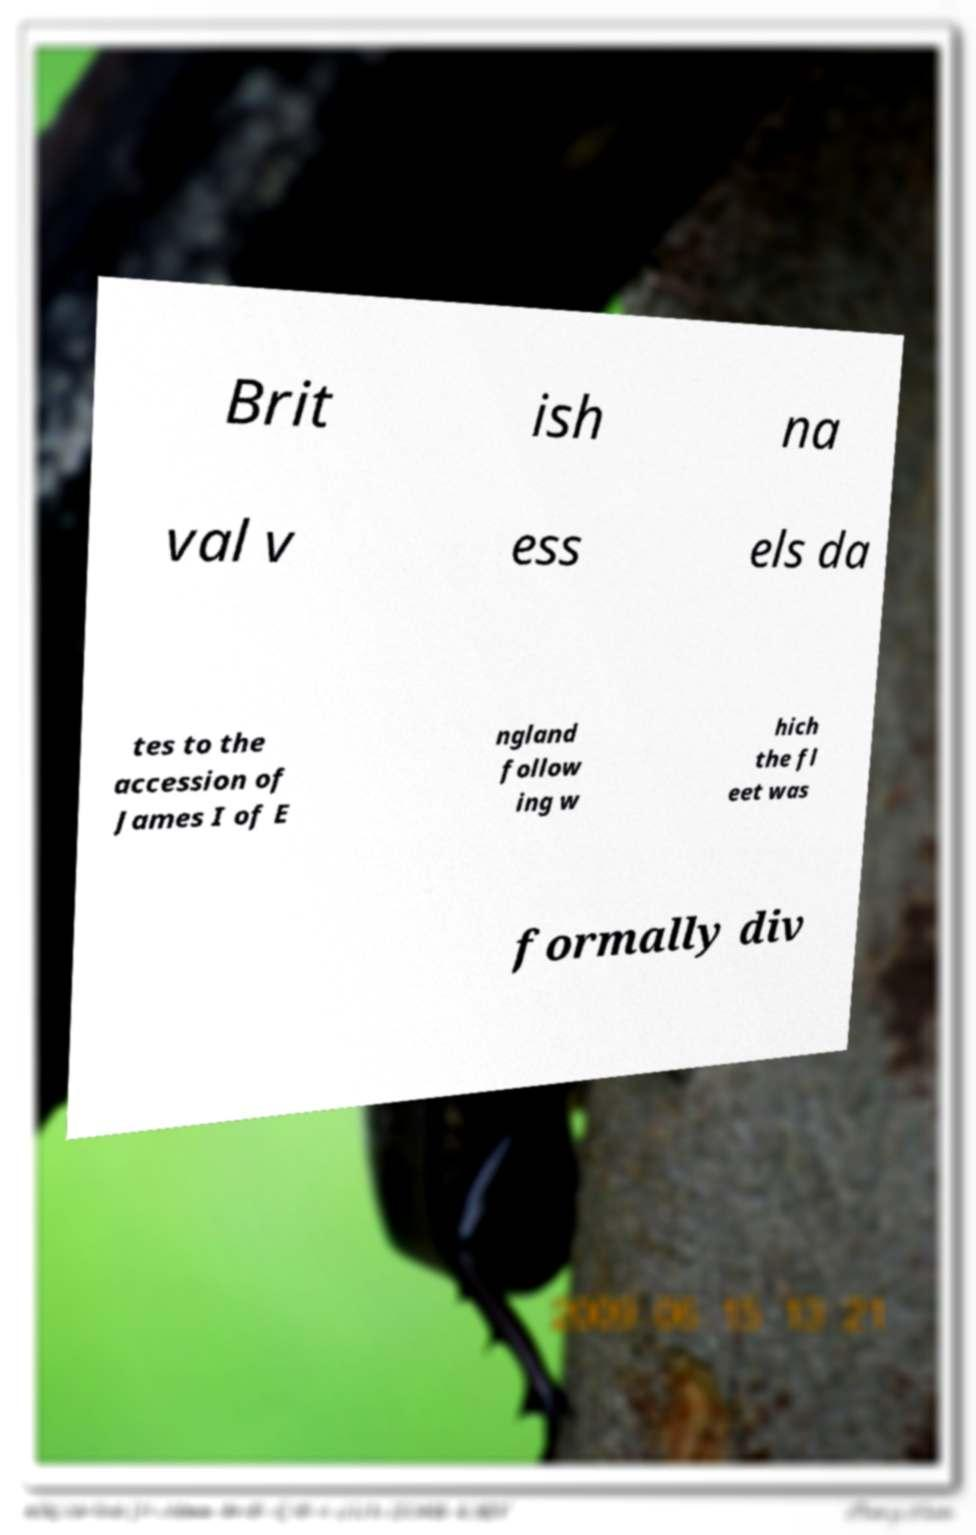Please identify and transcribe the text found in this image. Brit ish na val v ess els da tes to the accession of James I of E ngland follow ing w hich the fl eet was formally div 